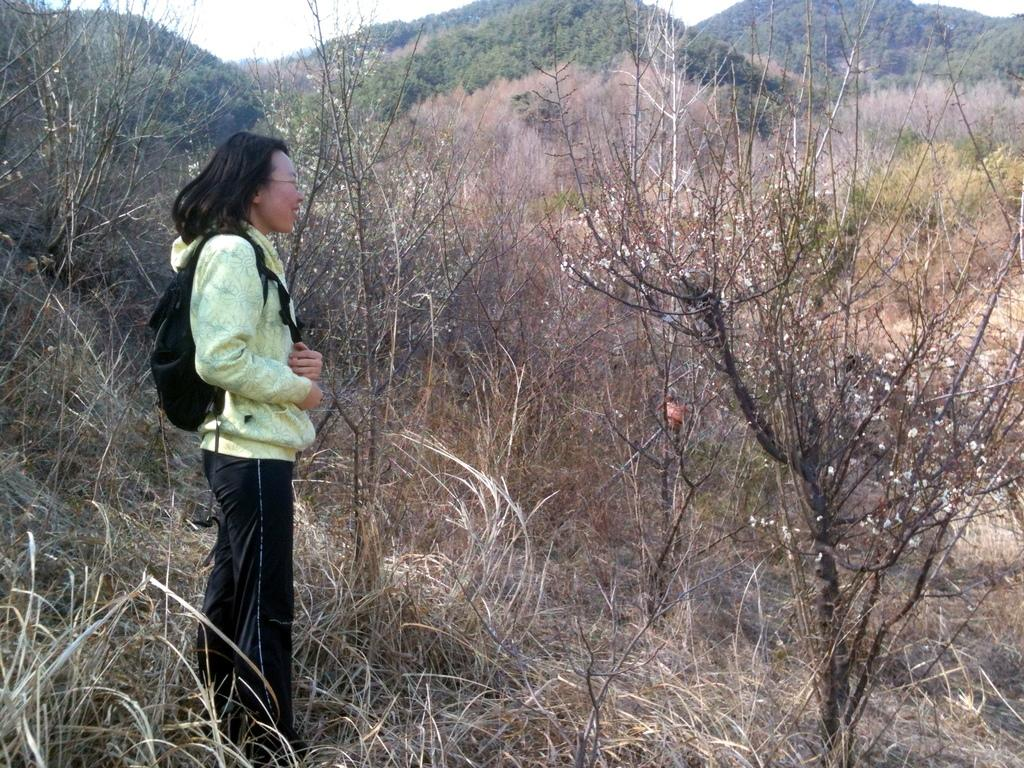What is the person in the image doing? The person is standing on the grass on the left side of the image. What type of vegetation can be seen in the image? There are trees in the image. What can be seen in the background of the image? There are trees, mountains, and the sky visible in the background of the image. How many bears are visible in the image? There are no bears present in the image. What type of light source is illuminating the scene in the image? The image does not provide information about the light source; it only shows the natural lighting from the sky. 